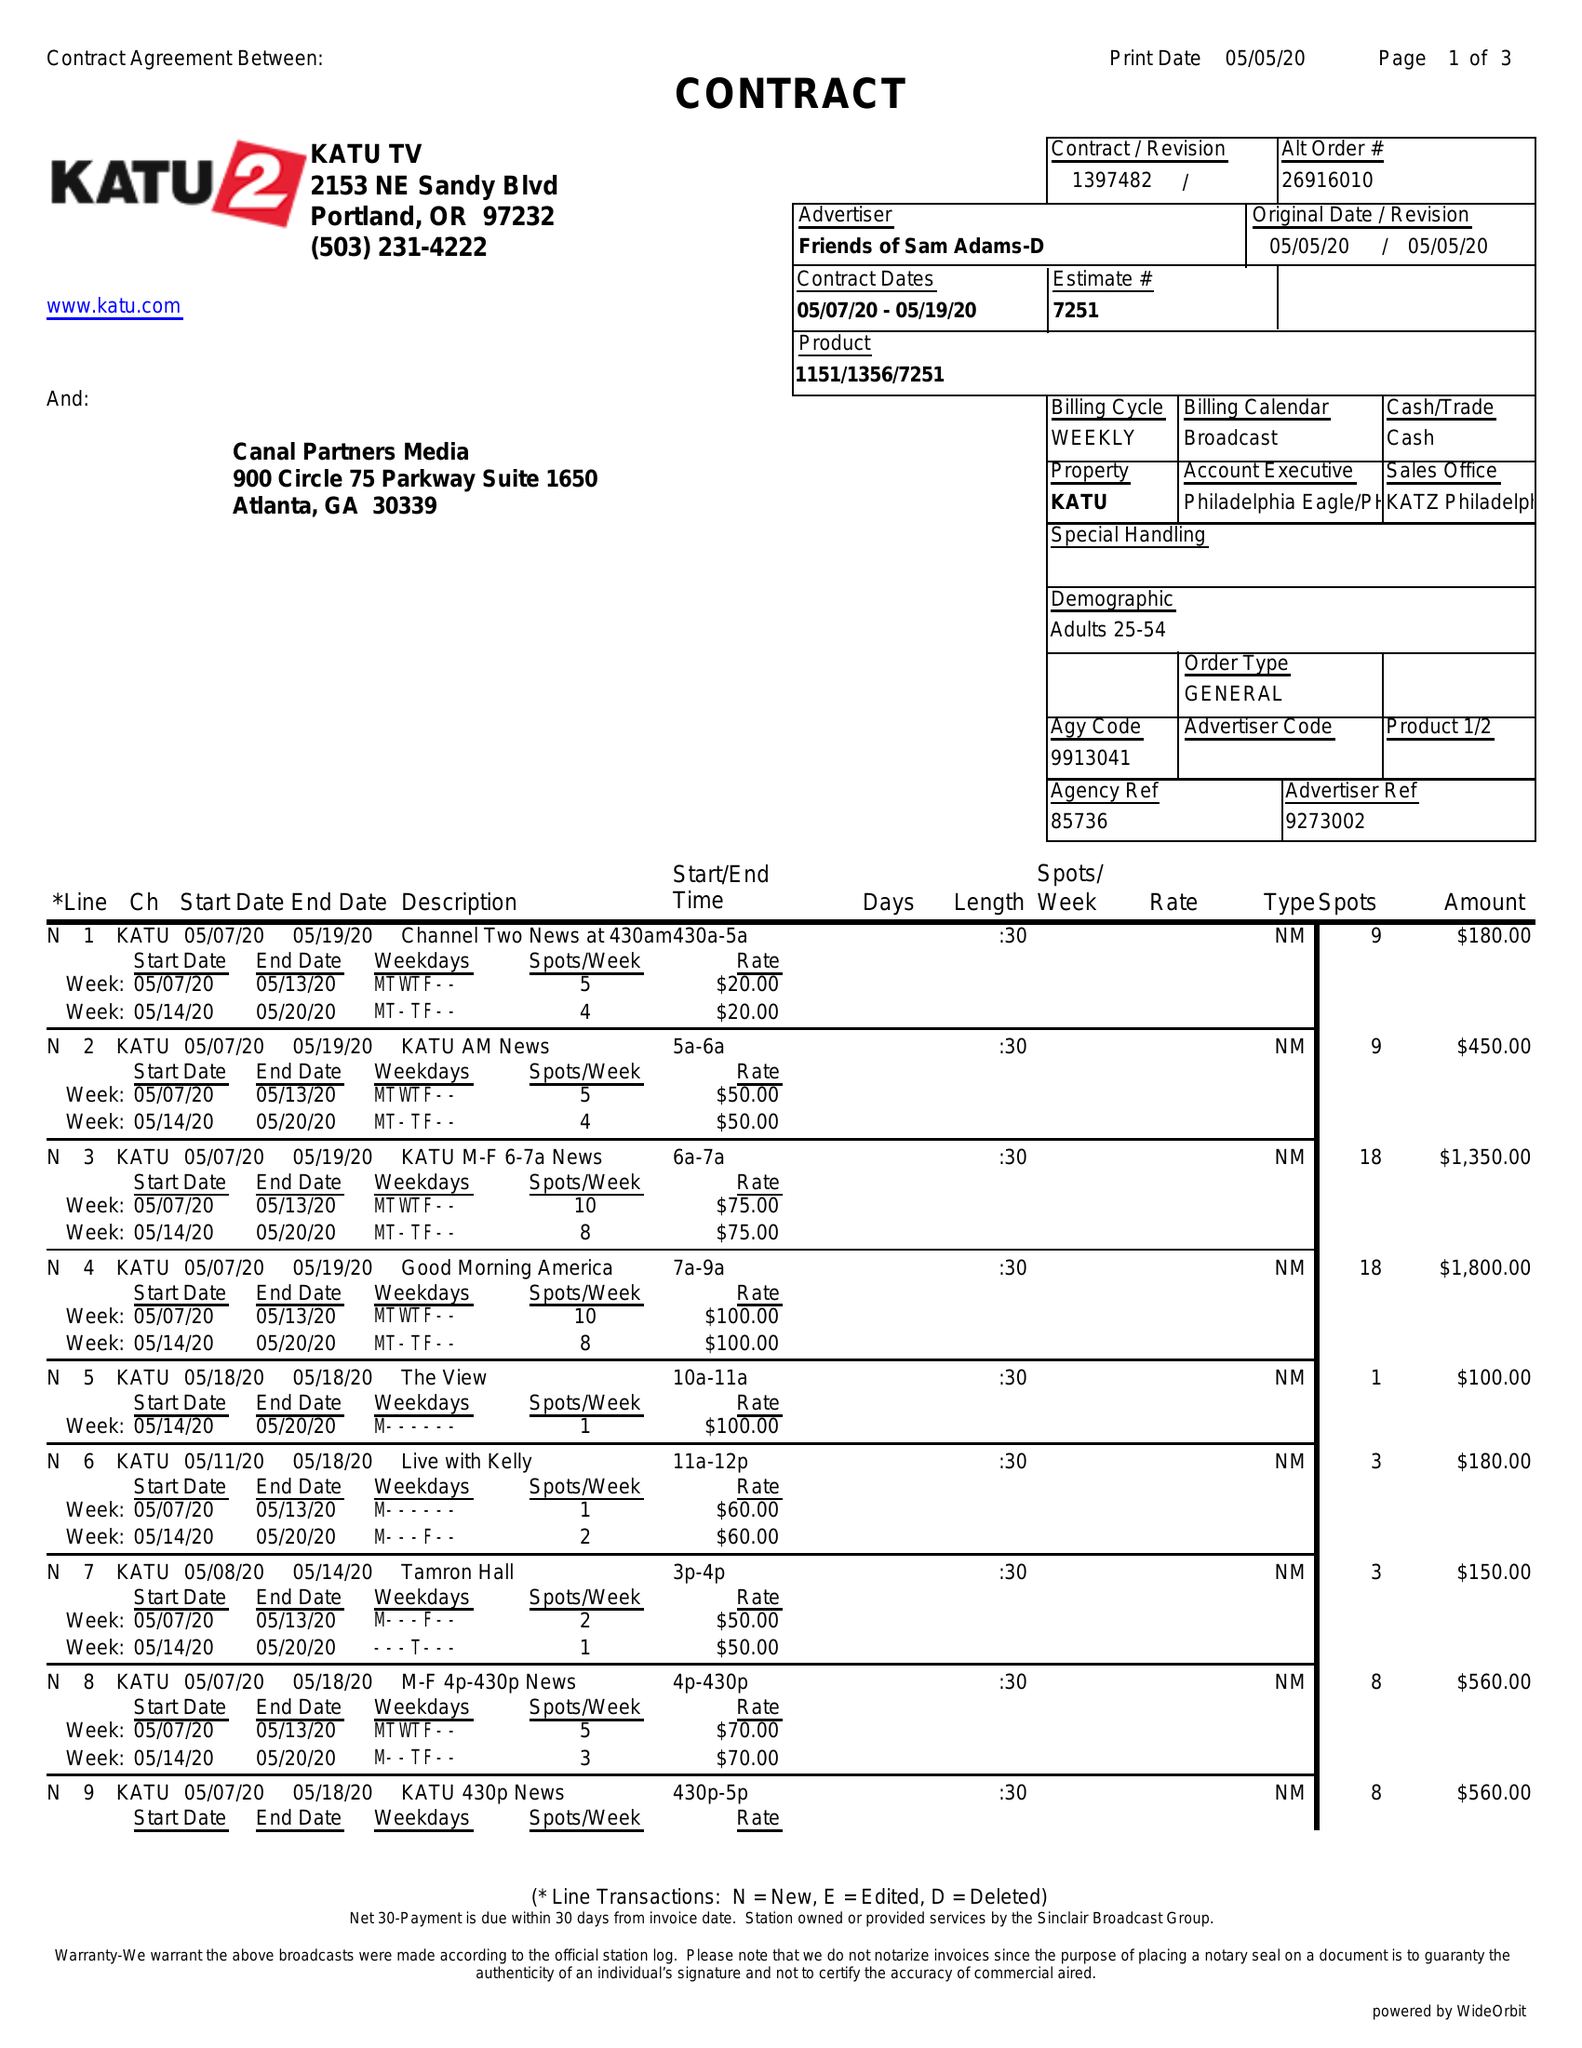What is the value for the advertiser?
Answer the question using a single word or phrase. FRIENDS OF SAM ADAMS-D 